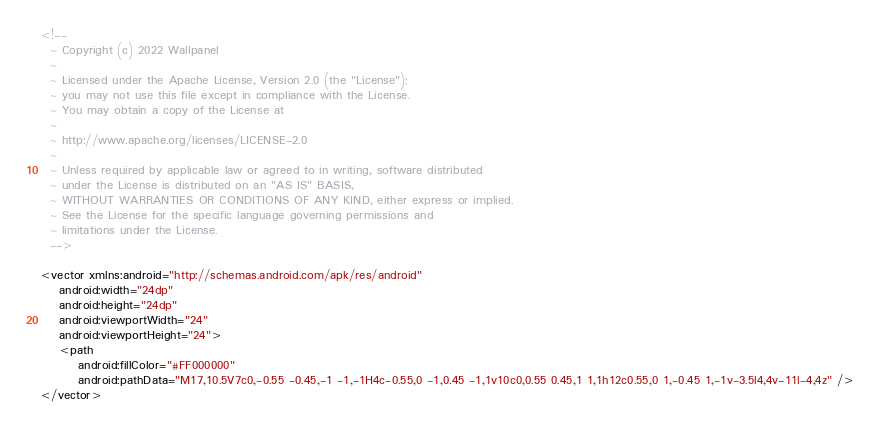<code> <loc_0><loc_0><loc_500><loc_500><_XML_><!--
  ~ Copyright (c) 2022 Wallpanel
  ~
  ~ Licensed under the Apache License, Version 2.0 (the "License");
  ~ you may not use this file except in compliance with the License.
  ~ You may obtain a copy of the License at
  ~
  ~ http://www.apache.org/licenses/LICENSE-2.0
  ~
  ~ Unless required by applicable law or agreed to in writing, software distributed
  ~ under the License is distributed on an "AS IS" BASIS,
  ~ WITHOUT WARRANTIES OR CONDITIONS OF ANY KIND, either express or implied.
  ~ See the License for the specific language governing permissions and
  ~ limitations under the License.
  -->

<vector xmlns:android="http://schemas.android.com/apk/res/android"
    android:width="24dp"
    android:height="24dp"
    android:viewportWidth="24"
    android:viewportHeight="24">
    <path
        android:fillColor="#FF000000"
        android:pathData="M17,10.5V7c0,-0.55 -0.45,-1 -1,-1H4c-0.55,0 -1,0.45 -1,1v10c0,0.55 0.45,1 1,1h12c0.55,0 1,-0.45 1,-1v-3.5l4,4v-11l-4,4z" />
</vector>
</code> 